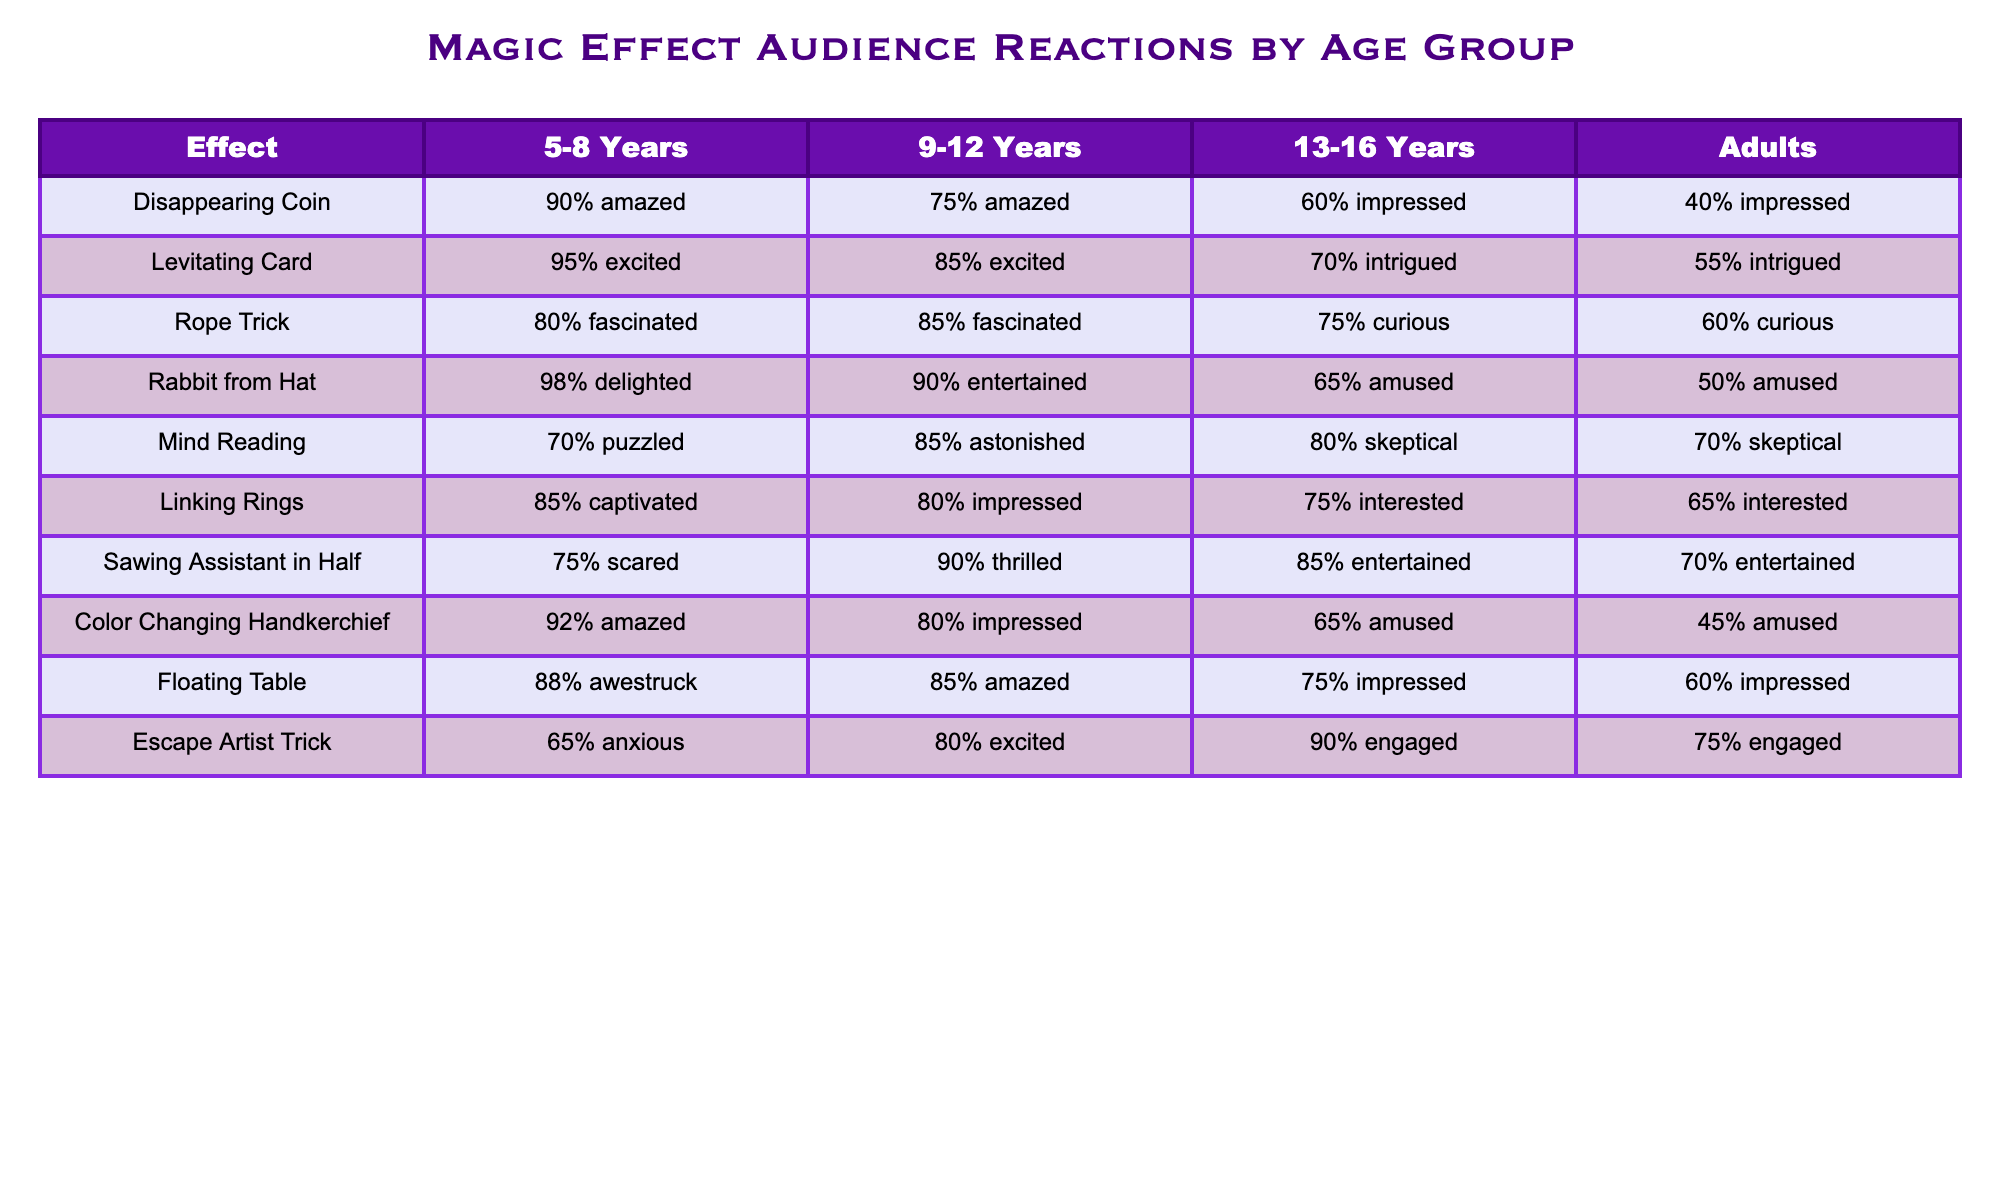What percentage of 5-8 year-olds were amazed by the Disappearing Coin? According to the table, the value for the Disappearing Coin in the 5-8 years age group is 90% amazed.
Answer: 90% Which magic effect had the highest percentage of "excited" responses from the 9-12 year-old age group? In the 9-12 years age group, the Levitating Card had 85% excited, which is the highest among all effects.
Answer: Levitating Card What is the average percentage of impressed reactions across all age groups for the Linking Rings? For the Linking Rings, the percentages for impressed are 75% for 13-16 years and 65% for adults. First, we add these values (75 + 65), giving 140. Then, we divide by the number of relevant responses, which is 2. Therefore, the average is 140 / 2 = 70%.
Answer: 70% True or False: More adults were entertained by the Sawing Assistant in Half than the Rabbit from Hat. The Rabbit from Hat had 50% amused reactions from adults, while the Sawing Assistant in Half had 70% entertained reactions. Thus, the statement is false.
Answer: False Which age group shows the most fascination with the Rope Trick? The Rope Trick received 85% fascinated reactions from both 9-12 years and adults, but the 5-8 year-olds had 80%, which is less than the older age groups. Thus, 9-12 years and adults are the most fascinated groups.
Answer: 9-12 years and adults What is the difference in percentage of amazed reactions between the Color Changing Handkerchief and the Floating Table for the 5-8 year-olds? The Color Changing Handkerchief has 92% amazed reactions and the Floating Table has 88% amazed reactions. We subtract: 92 - 88 = 4%.
Answer: 4% Which magic effect has the lowest percentage of intrigued reactions from Adults? For adults, the lowest intrigued reaction is from the Linking Rings, which has 65% interested reactions. Other effects either have higher or are less relevant in this context.
Answer: Linking Rings How do the percentages of excited reactions compare between the 9-12 years age group for Levitating Card and Escape Artist Trick? The Levitating Card has 85% excited reactions, while the Escape Artist Trick has none indicated in the table. The difference is significant, as 85% is much higher than 0%.
Answer: 85% What is the maximum percentage of scared reactions across all age groups, and which effect caused it? The maximum percentage of scared reactions is 75% from the Sawing Assistant in Half for the 5-8 year-old age group. This can be seen directly in the table.
Answer: 75% from Sawing Assistant in Half 